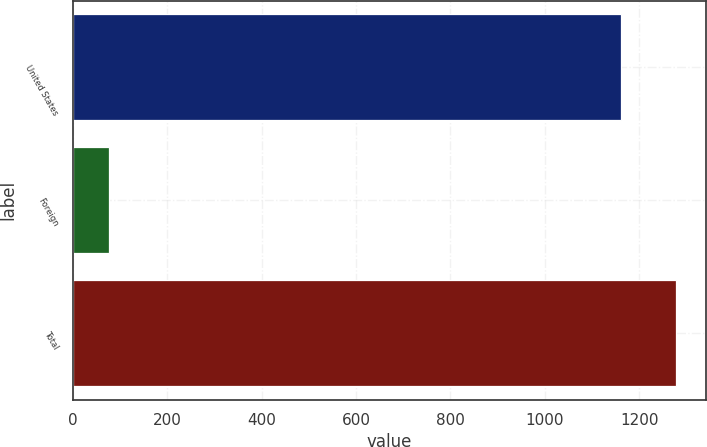Convert chart to OTSL. <chart><loc_0><loc_0><loc_500><loc_500><bar_chart><fcel>United States<fcel>Foreign<fcel>Total<nl><fcel>1161<fcel>77<fcel>1277.1<nl></chart> 